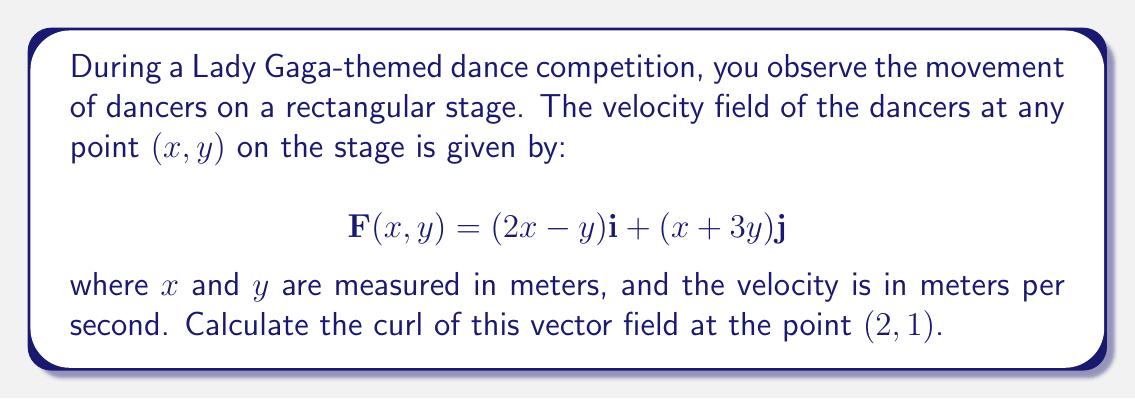Teach me how to tackle this problem. To solve this problem, we'll follow these steps:

1) The curl of a vector field $\mathbf{F}(x,y) = P(x,y)\mathbf{i} + Q(x,y)\mathbf{j}$ in two dimensions is given by:

   $$\text{curl }\mathbf{F} = \nabla \times \mathbf{F} = \left(\frac{\partial Q}{\partial x} - \frac{\partial P}{\partial y}\right)\mathbf{k}$$

2) In our case, $P(x,y) = 2x-y$ and $Q(x,y) = x+3y$

3) Let's calculate the partial derivatives:

   $\frac{\partial Q}{\partial x} = \frac{\partial}{\partial x}(x+3y) = 1$

   $\frac{\partial P}{\partial y} = \frac{\partial}{\partial y}(2x-y) = -1$

4) Now, we can substitute these into the curl formula:

   $$\text{curl }\mathbf{F} = (1 - (-1))\mathbf{k} = 2\mathbf{k}$$

5) This result is constant for all points in the field, including the point $(2,1)$.

Therefore, the curl of the vector field at point $(2,1)$ is $2\mathbf{k}$.
Answer: $2\mathbf{k}$ 